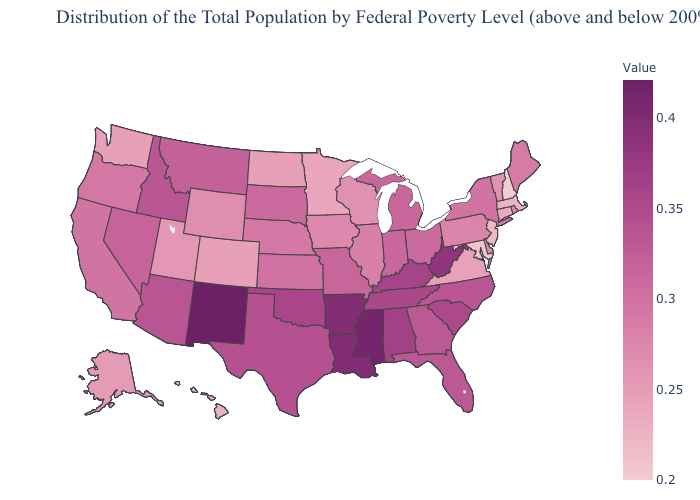Which states have the highest value in the USA?
Give a very brief answer. New Mexico. Among the states that border Minnesota , which have the lowest value?
Give a very brief answer. North Dakota. Among the states that border Missouri , does Illinois have the lowest value?
Keep it brief. No. Among the states that border Arizona , which have the highest value?
Write a very short answer. New Mexico. Which states have the lowest value in the USA?
Give a very brief answer. New Hampshire. Does Georgia have the lowest value in the USA?
Answer briefly. No. Which states have the lowest value in the USA?
Write a very short answer. New Hampshire. 